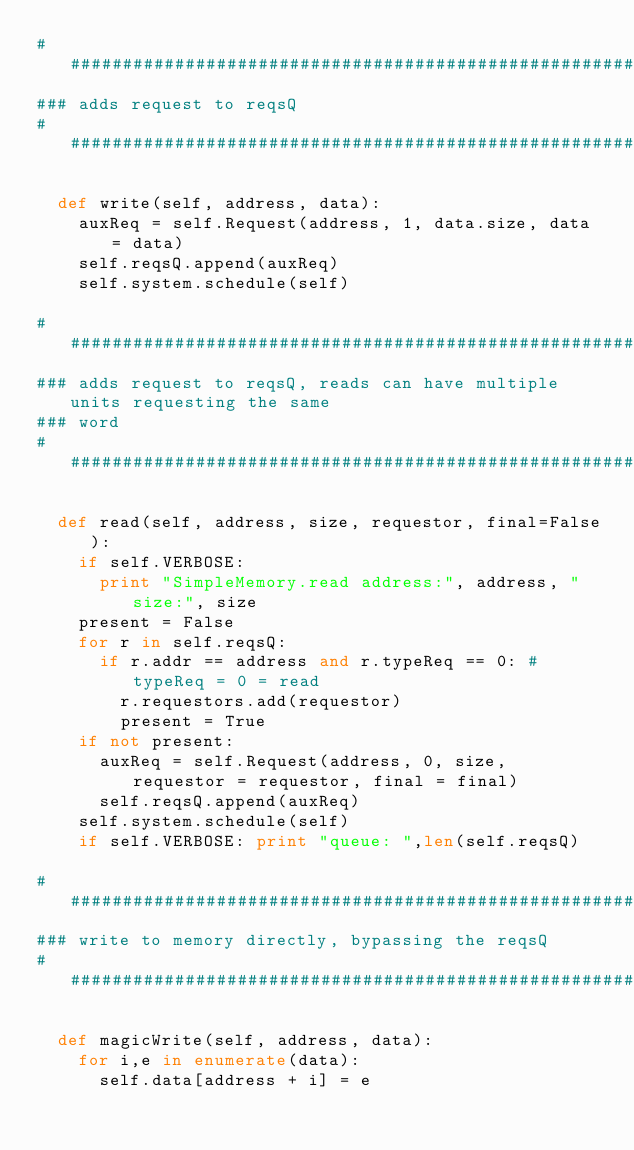<code> <loc_0><loc_0><loc_500><loc_500><_Python_>##################################################################################
### adds request to reqsQ 
##################################################################################
  
  def write(self, address, data):
    auxReq = self.Request(address, 1, data.size, data = data)
    self.reqsQ.append(auxReq)
    self.system.schedule(self)

##################################################################################
### adds request to reqsQ, reads can have multiple units requesting the same 
### word
##################################################################################
 
  def read(self, address, size, requestor, final=False):
    if self.VERBOSE: 
      print "SimpleMemory.read address:", address, " size:", size 
    present = False
    for r in self.reqsQ:
      if r.addr == address and r.typeReq == 0: # typeReq = 0 = read
        r.requestors.add(requestor)
        present = True
    if not present:
      auxReq = self.Request(address, 0, size, requestor = requestor, final = final) 
      self.reqsQ.append(auxReq)
    self.system.schedule(self)
    if self.VERBOSE: print "queue: ",len(self.reqsQ) 

##################################################################################
### write to memory directly, bypassing the reqsQ
##################################################################################
 
  def magicWrite(self, address, data):
    for i,e in enumerate(data):
      self.data[address + i] = e


</code> 